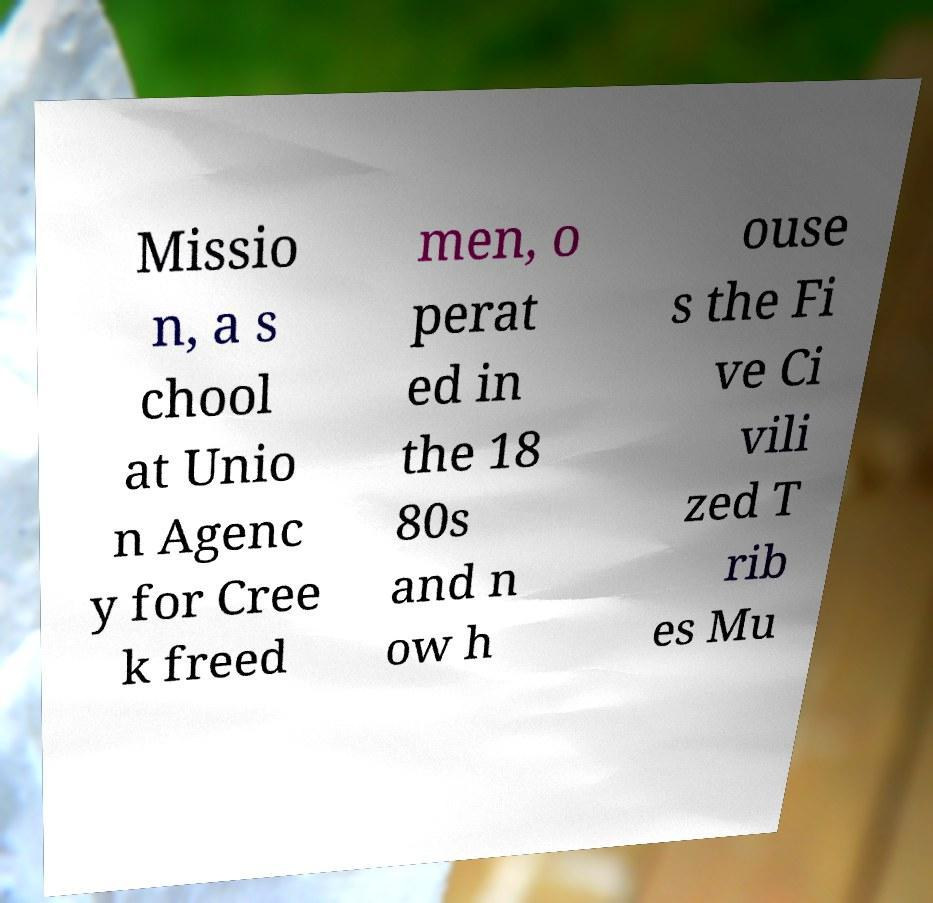Please identify and transcribe the text found in this image. Missio n, a s chool at Unio n Agenc y for Cree k freed men, o perat ed in the 18 80s and n ow h ouse s the Fi ve Ci vili zed T rib es Mu 